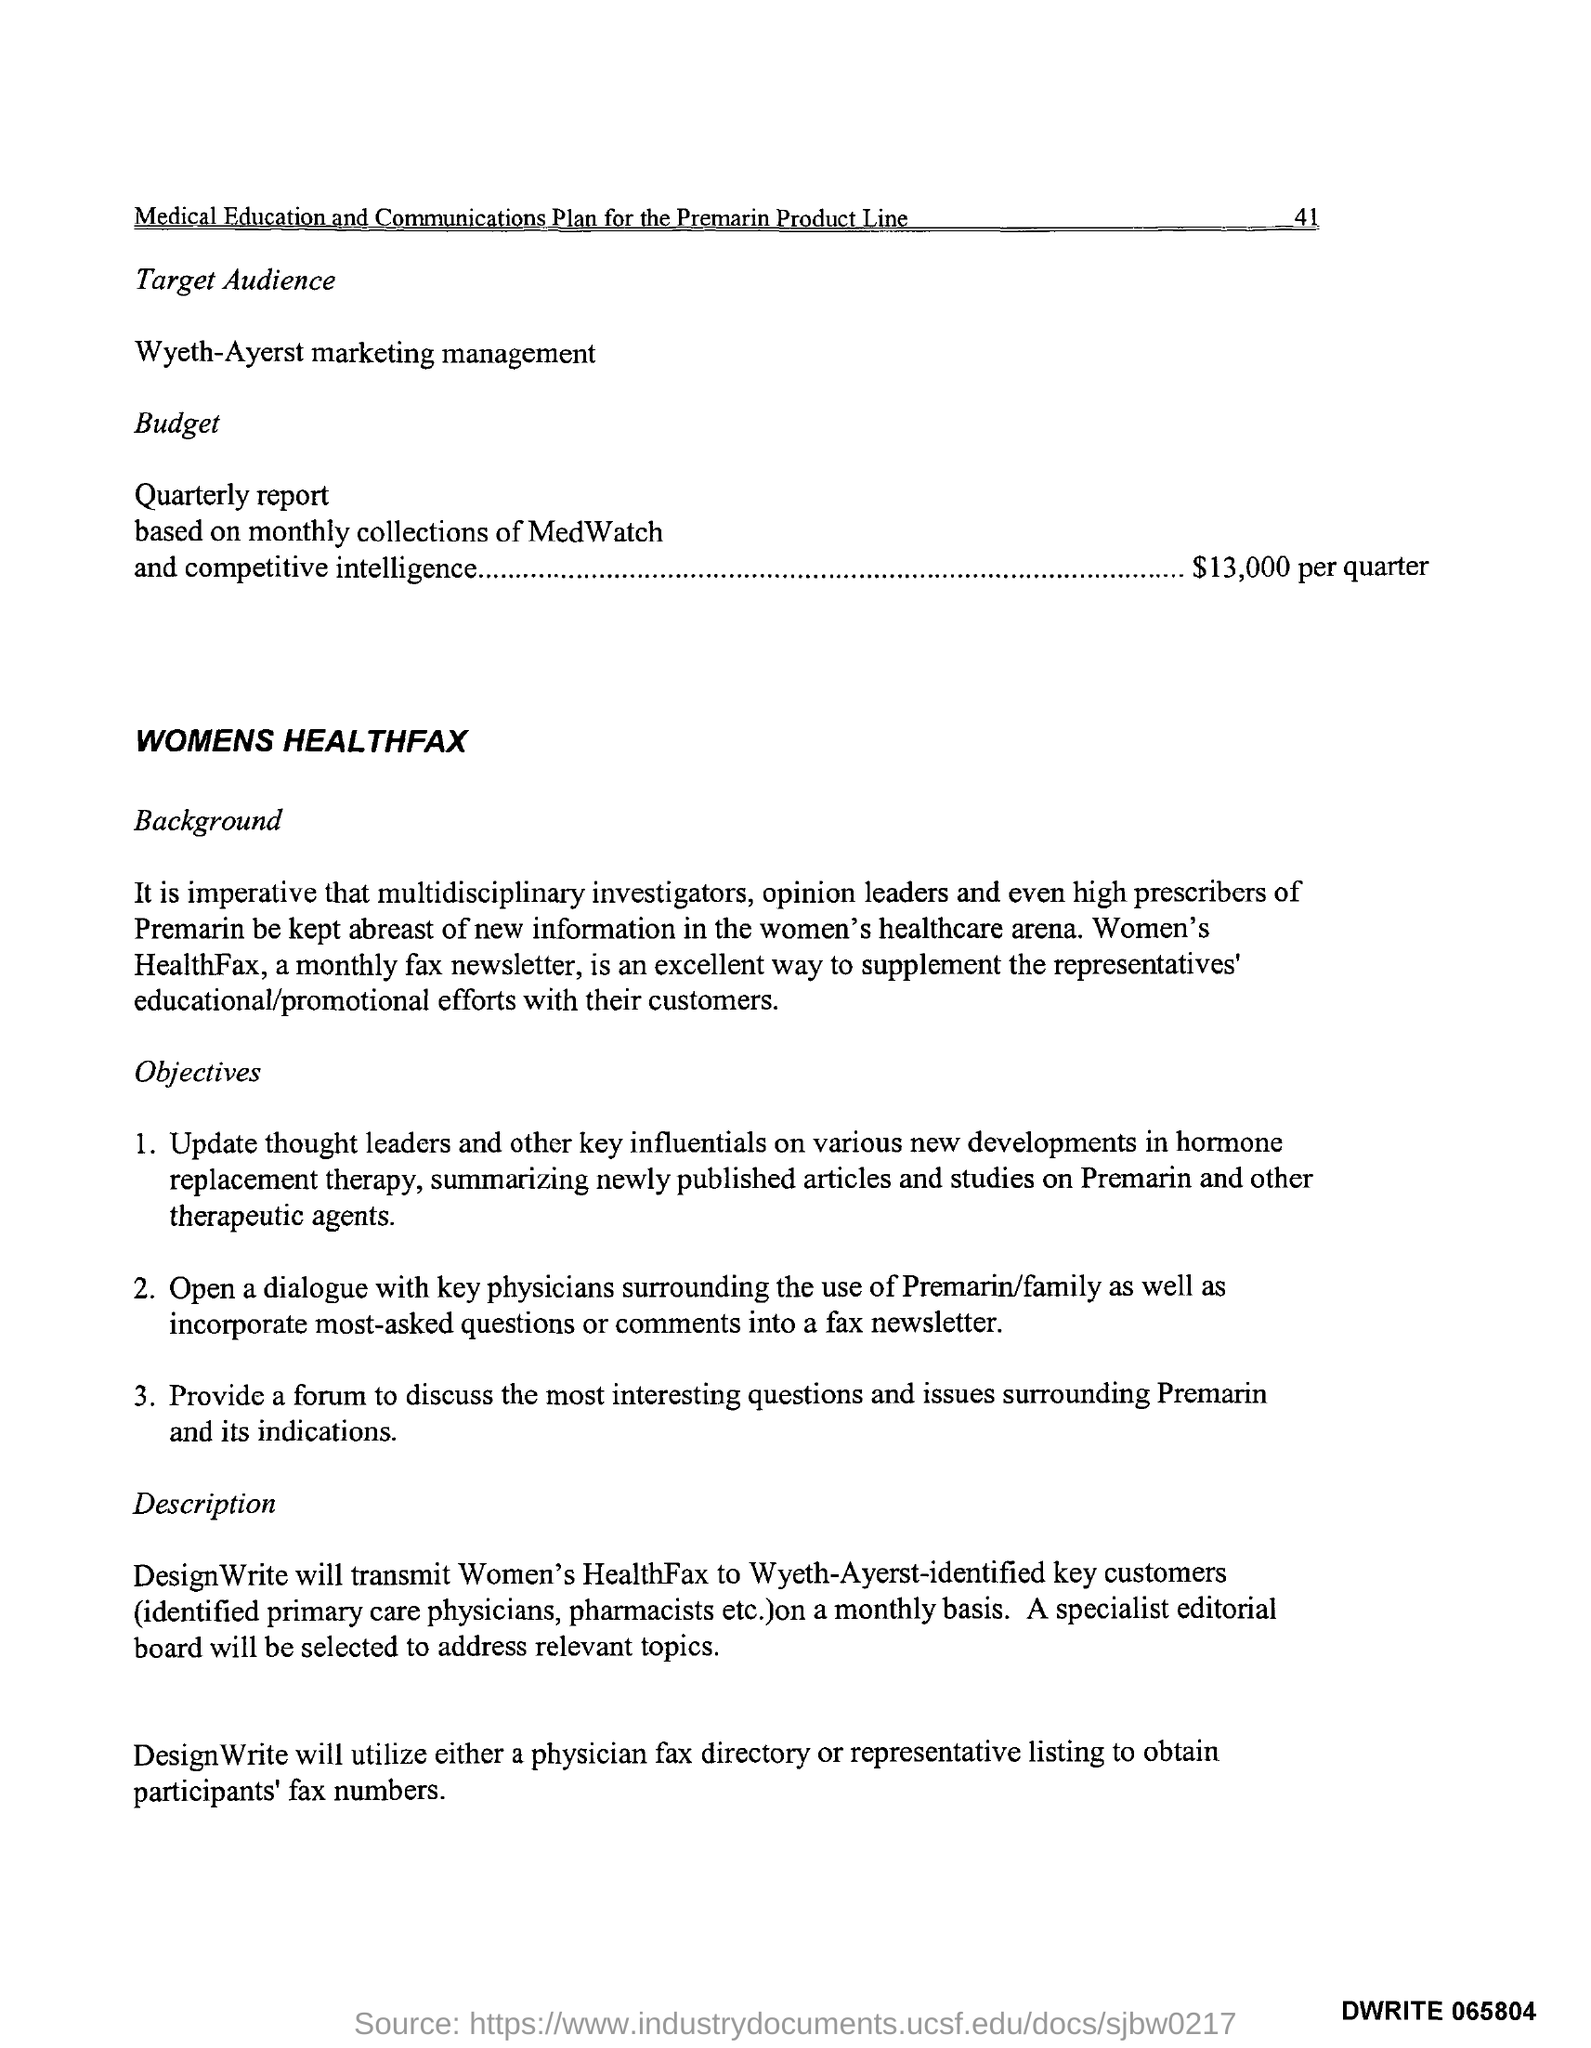Highlight a few significant elements in this photo. The budget for the quarterly report is $13,000 per quarter. What is the name of the monthly fax newsletter that focuses on women's health? It is called Women's Healthfax. 